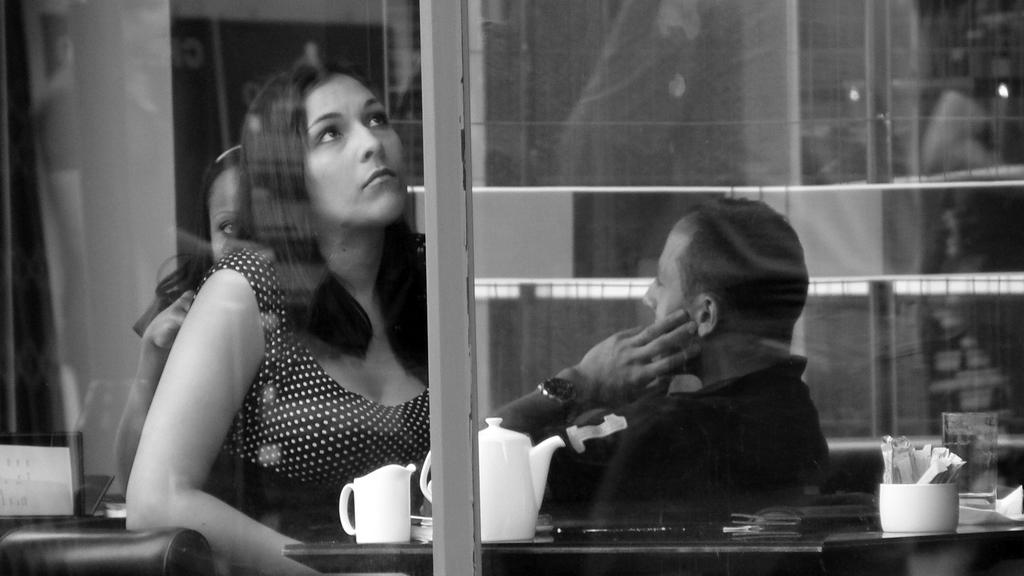What are the persons in the image doing? The persons in the image are sitting in the center. What is in front of the sitting persons? There is a table in front of the sitting persons. What can be seen on the table? There are cups and a jar on the table. Can you describe an object in the background of the image? There is a glass in the background of the image. What type of nut is being cracked on the sofa in the image? There is no sofa or nut present in the image; it only features persons sitting, a table, cups, a jar, and a glass in the background. 